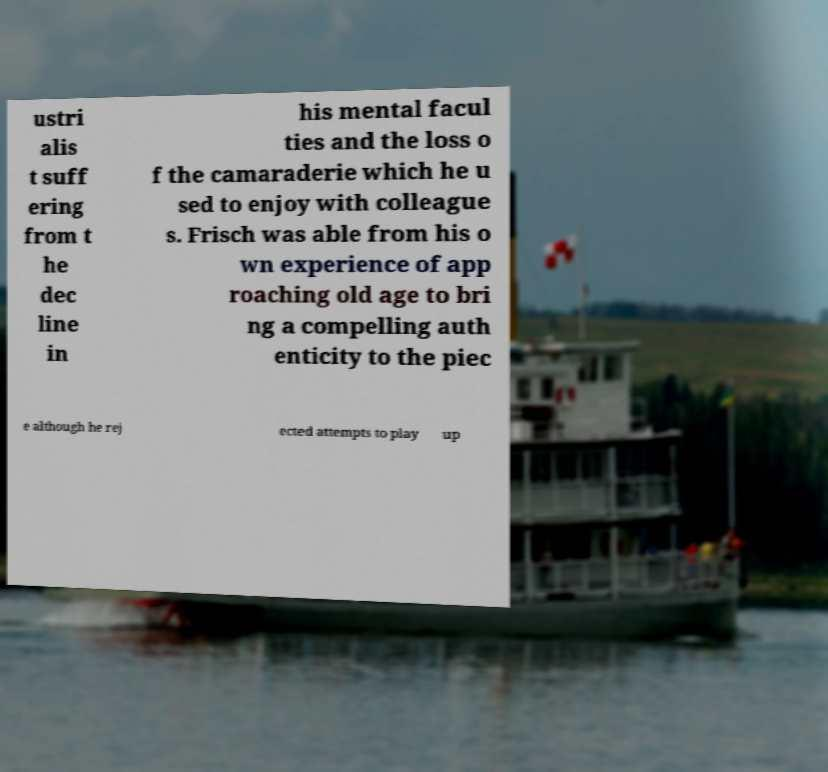There's text embedded in this image that I need extracted. Can you transcribe it verbatim? ustri alis t suff ering from t he dec line in his mental facul ties and the loss o f the camaraderie which he u sed to enjoy with colleague s. Frisch was able from his o wn experience of app roaching old age to bri ng a compelling auth enticity to the piec e although he rej ected attempts to play up 